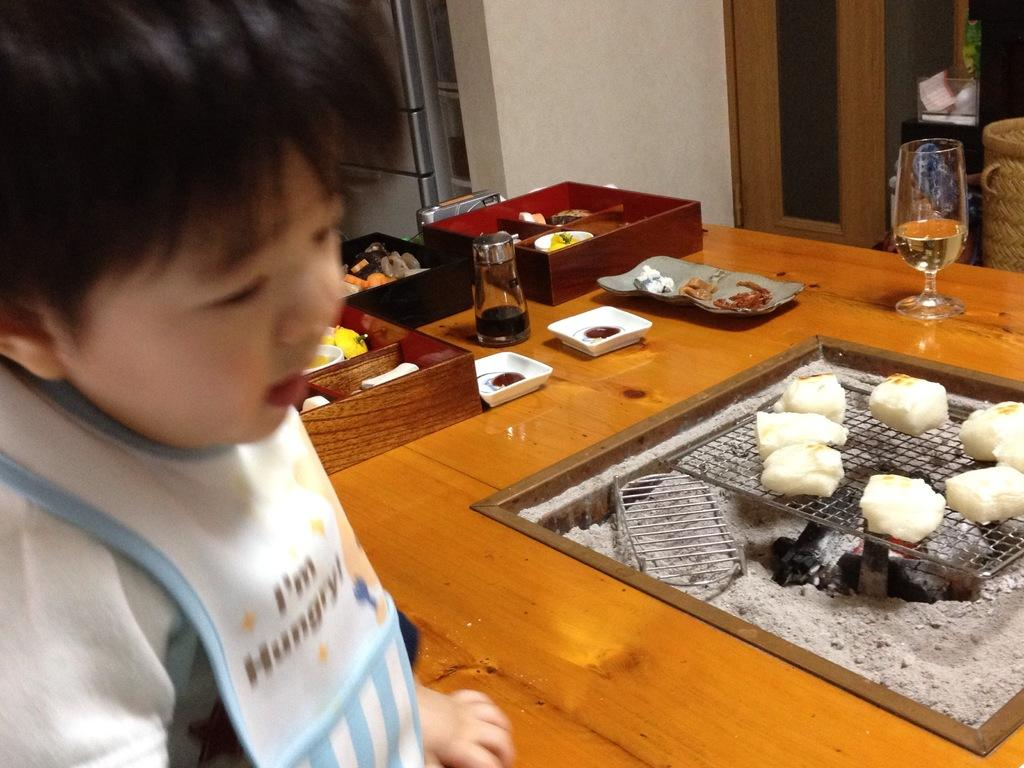What can be seen in the background of the image? There is a wall, a refrigerator, and a window in the background of the image. What is on the table in the image? There is a grill cooking food, plates, a bottle, and a glass on the table. What is the boy in the image doing? The information provided does not specify what the boy is doing. What type of appliance is present in the background of the image? There is a refrigerator in the background of the image. What type of grain is being used to make the pie on the table? There is no pie present on the table in the image. What button is the boy pressing to control the grill? There is no button visible on the grill in the image. 